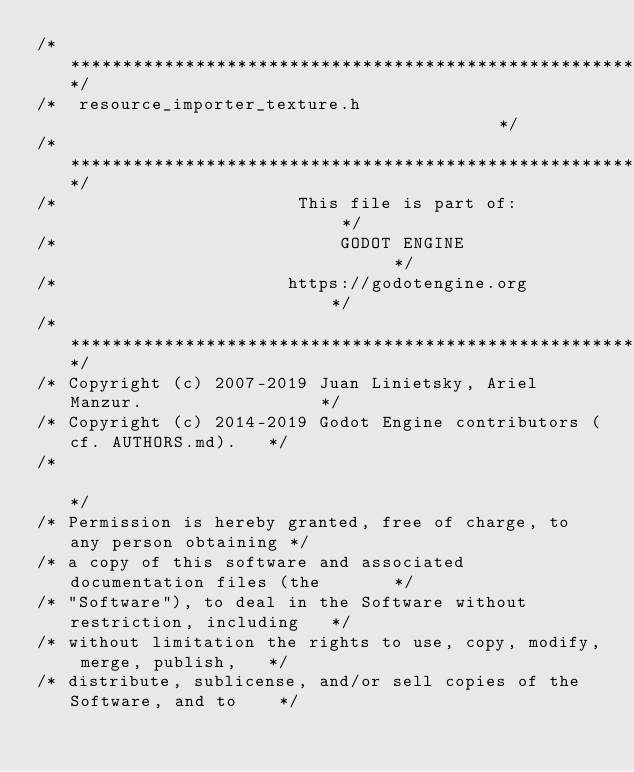Convert code to text. <code><loc_0><loc_0><loc_500><loc_500><_C_>/*************************************************************************/
/*  resource_importer_texture.h                                          */
/*************************************************************************/
/*                       This file is part of:                           */
/*                           GODOT ENGINE                                */
/*                      https://godotengine.org                          */
/*************************************************************************/
/* Copyright (c) 2007-2019 Juan Linietsky, Ariel Manzur.                 */
/* Copyright (c) 2014-2019 Godot Engine contributors (cf. AUTHORS.md).   */
/*                                                                       */
/* Permission is hereby granted, free of charge, to any person obtaining */
/* a copy of this software and associated documentation files (the       */
/* "Software"), to deal in the Software without restriction, including   */
/* without limitation the rights to use, copy, modify, merge, publish,   */
/* distribute, sublicense, and/or sell copies of the Software, and to    */</code> 